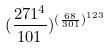<formula> <loc_0><loc_0><loc_500><loc_500>( \frac { 2 7 1 ^ { 4 } } { 1 0 1 } ) ^ { ( \frac { 6 8 } { 3 0 1 } ) ^ { 1 2 3 } }</formula> 